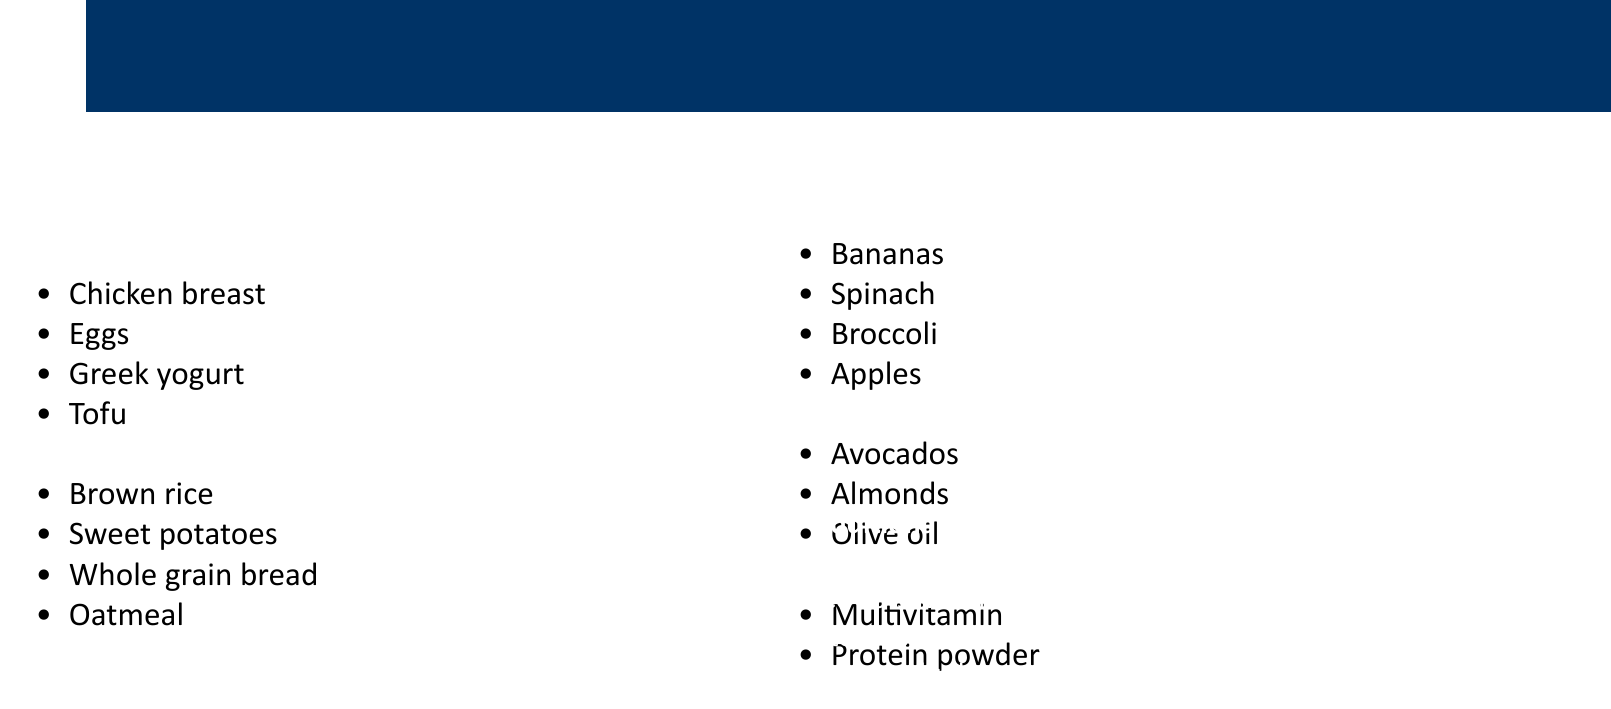what is the total cost of chicken breast? The cost of chicken breast is listed as $25 in the document.
Answer: $25 how much do eggs cost? The document states that eggs cost $10.
Answer: $10 what are two examples of complex carbohydrates? The document lists brown rice and sweet potatoes as examples of complex carbohydrates.
Answer: brown rice, sweet potatoes how much do apples cost? The cost of apples is provided as $7 in the document.
Answer: $7 what is the cost of a multivitamin? The document indicates that a multivitamin costs $15.
Answer: $15 how many types of healthy fats are listed? The document lists three types of healthy fats: avocados, almonds, and olive oil.
Answer: three what are the suggestions for saving time and sticking to the budget? The document advises preparing meals in advance to save time and stick to the budget.
Answer: prepare meals in advance which protein source is the least expensive? Tofu is listed as the least expensive protein source at $8.
Answer: Tofu who's quote is included in the document? The quote attributed to Jigoro Kano is included in the document.
Answer: Jigoro Kano 